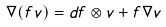<formula> <loc_0><loc_0><loc_500><loc_500>\nabla ( f v ) = d f \otimes v + f \nabla v</formula> 